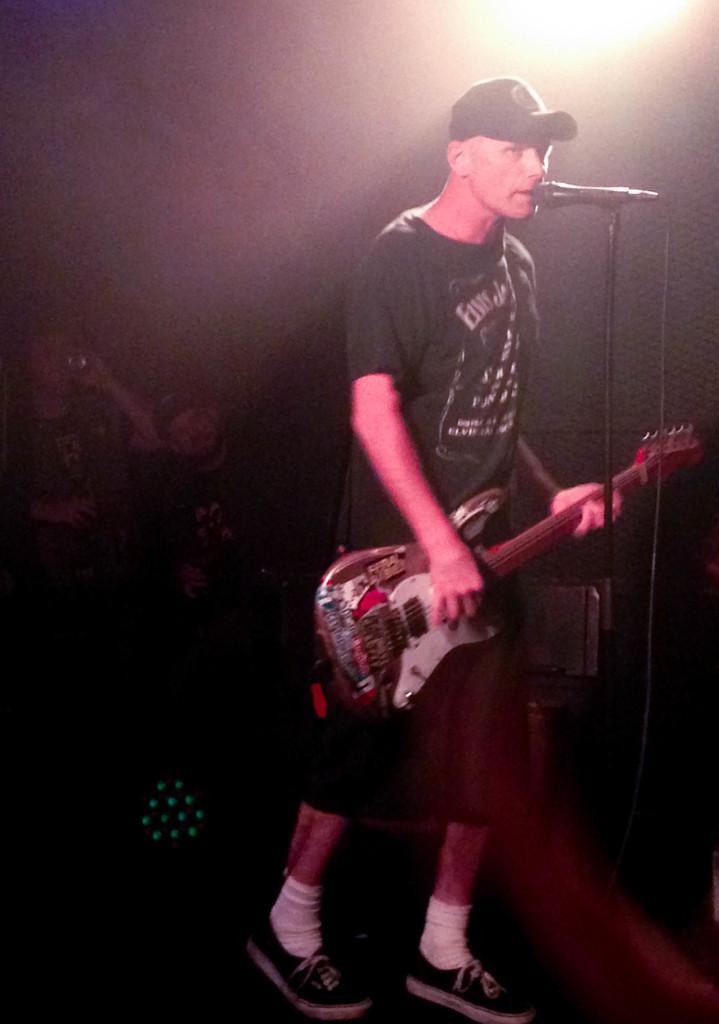Could you give a brief overview of what you see in this image? This picture shows a man standing on the stage, holding a guitar in his hands. He is wearing a cap, singing in front of a mic and a stand. In the background there is a light. 